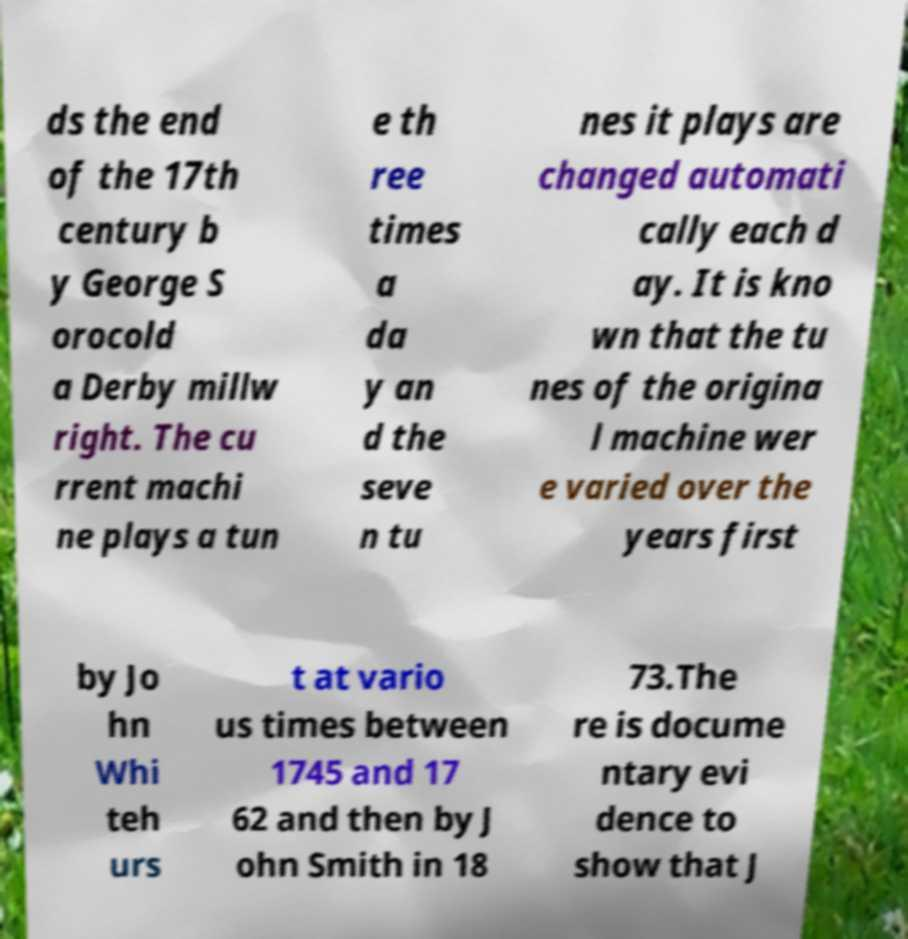Could you assist in decoding the text presented in this image and type it out clearly? ds the end of the 17th century b y George S orocold a Derby millw right. The cu rrent machi ne plays a tun e th ree times a da y an d the seve n tu nes it plays are changed automati cally each d ay. It is kno wn that the tu nes of the origina l machine wer e varied over the years first by Jo hn Whi teh urs t at vario us times between 1745 and 17 62 and then by J ohn Smith in 18 73.The re is docume ntary evi dence to show that J 